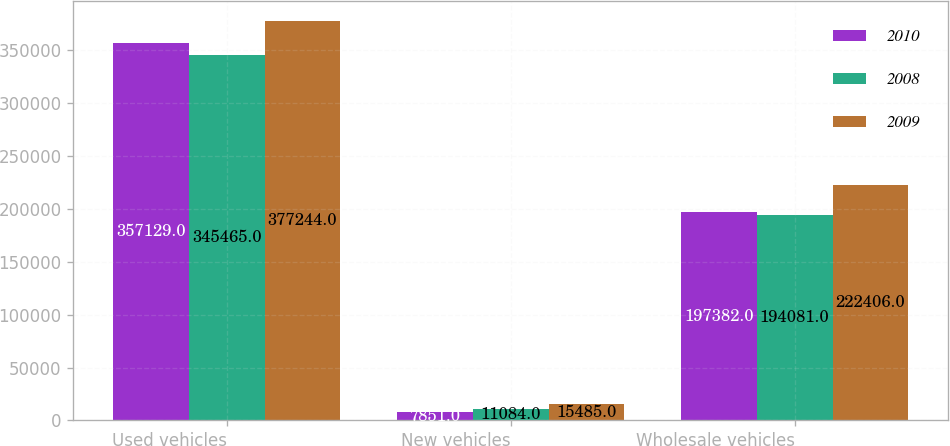Convert chart to OTSL. <chart><loc_0><loc_0><loc_500><loc_500><stacked_bar_chart><ecel><fcel>Used vehicles<fcel>New vehicles<fcel>Wholesale vehicles<nl><fcel>2010<fcel>357129<fcel>7851<fcel>197382<nl><fcel>2008<fcel>345465<fcel>11084<fcel>194081<nl><fcel>2009<fcel>377244<fcel>15485<fcel>222406<nl></chart> 